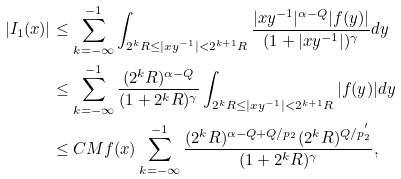Convert formula to latex. <formula><loc_0><loc_0><loc_500><loc_500>| I _ { 1 } ( x ) | & \leq \sum _ { k = - \infty } ^ { - 1 } \int _ { 2 ^ { k } R \leq | x y ^ { - 1 } | < 2 ^ { k + 1 } R } \frac { | x y ^ { - 1 } | ^ { \alpha - Q } | f ( y ) | } { ( 1 + | x y ^ { - 1 } | ) ^ { \gamma } } d y \\ & \leq \sum _ { k = - \infty } ^ { - 1 } \frac { ( 2 ^ { k } R ) ^ { \alpha - Q } } { ( 1 + 2 ^ { k } R ) ^ { \gamma } } \int _ { 2 ^ { k } R \leq | x y ^ { - 1 } | < 2 ^ { k + 1 } R } | f ( y ) | d y \\ & \leq C M f ( x ) \sum _ { k = - \infty } ^ { - 1 } \frac { ( 2 ^ { k } R ) ^ { \alpha - Q + Q / p _ { 2 } } ( 2 ^ { k } R ) ^ { Q / p _ { 2 } ^ { ^ { \prime } } } } { ( 1 + 2 ^ { k } R ) ^ { \gamma } } ,</formula> 